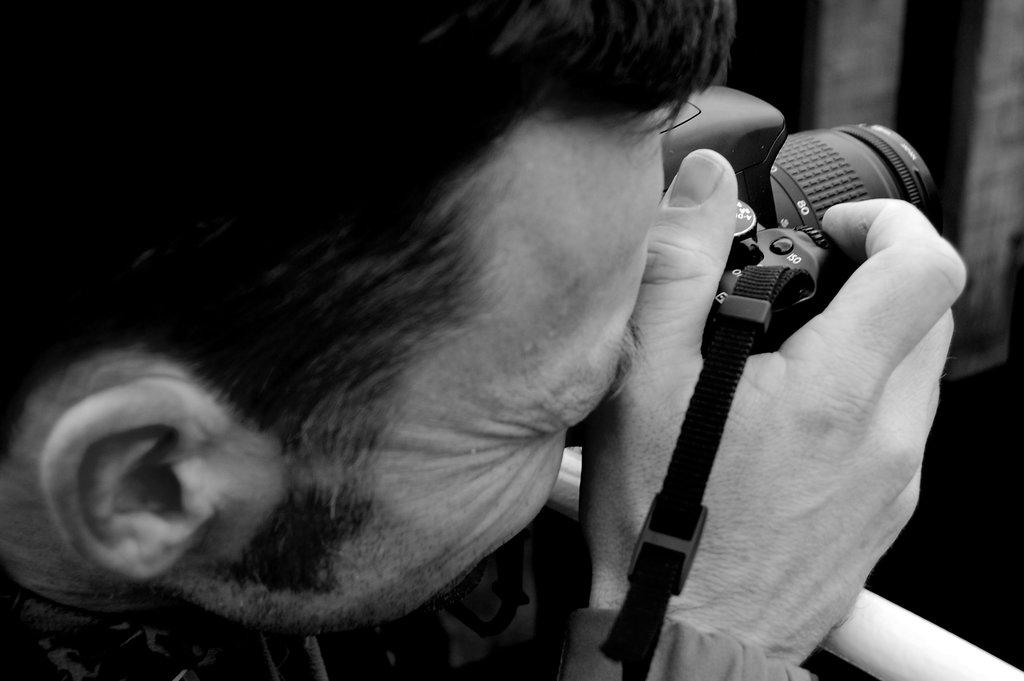What type of picture is in the image? The image contains a black and white picture. Who is featured in the black and white picture? The black and white picture features a man. What is the man holding in his hand? The man is holding a camera in his hand. What type of ice is the man holding in the image? There is no ice present in the image; the man is holding a camera. What is the name of the farmer in the image? There is no farmer present in the image, only a man holding a camera. 